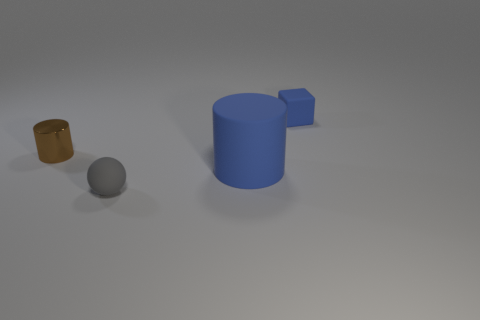Add 3 small red balls. How many objects exist? 7 Subtract all blue cylinders. How many cylinders are left? 1 Subtract all cubes. How many objects are left? 3 Subtract 1 cylinders. How many cylinders are left? 1 Subtract all brown cylinders. How many brown cubes are left? 0 Subtract 0 purple blocks. How many objects are left? 4 Subtract all green balls. Subtract all gray blocks. How many balls are left? 1 Subtract all large rubber things. Subtract all tiny gray matte objects. How many objects are left? 2 Add 4 big things. How many big things are left? 5 Add 3 big blue cylinders. How many big blue cylinders exist? 4 